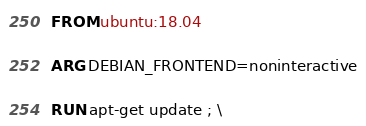<code> <loc_0><loc_0><loc_500><loc_500><_Dockerfile_>FROM ubuntu:18.04

ARG DEBIAN_FRONTEND=noninteractive

RUN apt-get update ; \</code> 